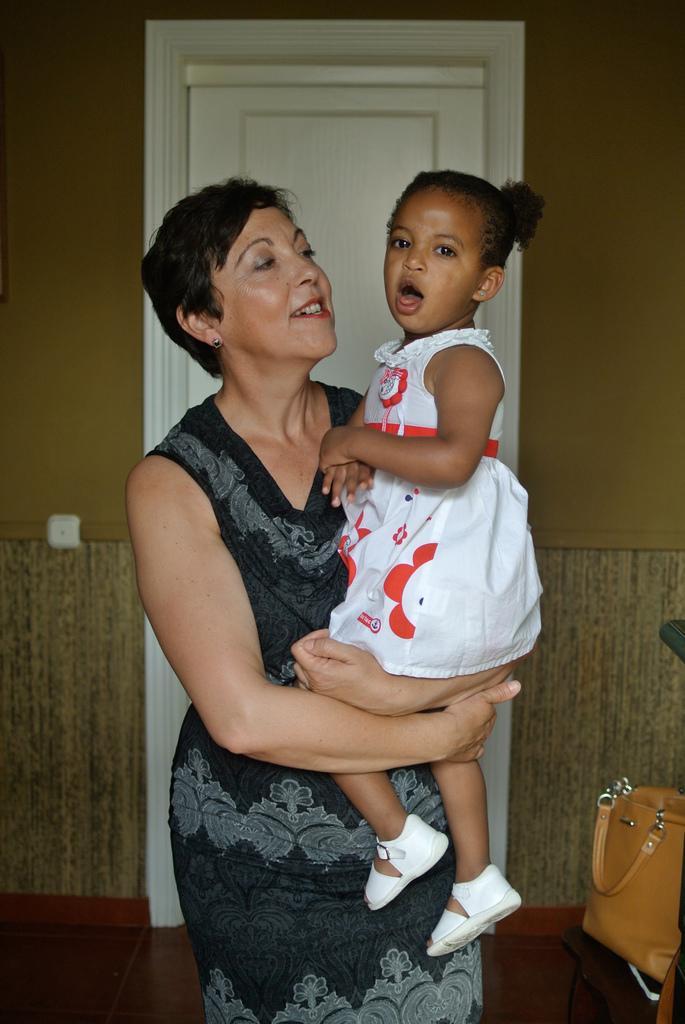In one or two sentences, can you explain what this image depicts? In this image one woman is holding the girl and behind woman one door is there and beside the woman one bag is there. 